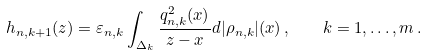Convert formula to latex. <formula><loc_0><loc_0><loc_500><loc_500>h _ { { n } , k + 1 } ( z ) = \varepsilon _ { { n } , k } \int _ { \Delta _ { k } } \frac { q ^ { 2 } _ { { n } , k } ( x ) } { z - x } d | \rho _ { { n } , k } | ( x ) \, , \quad k = 1 , \dots , m \, .</formula> 